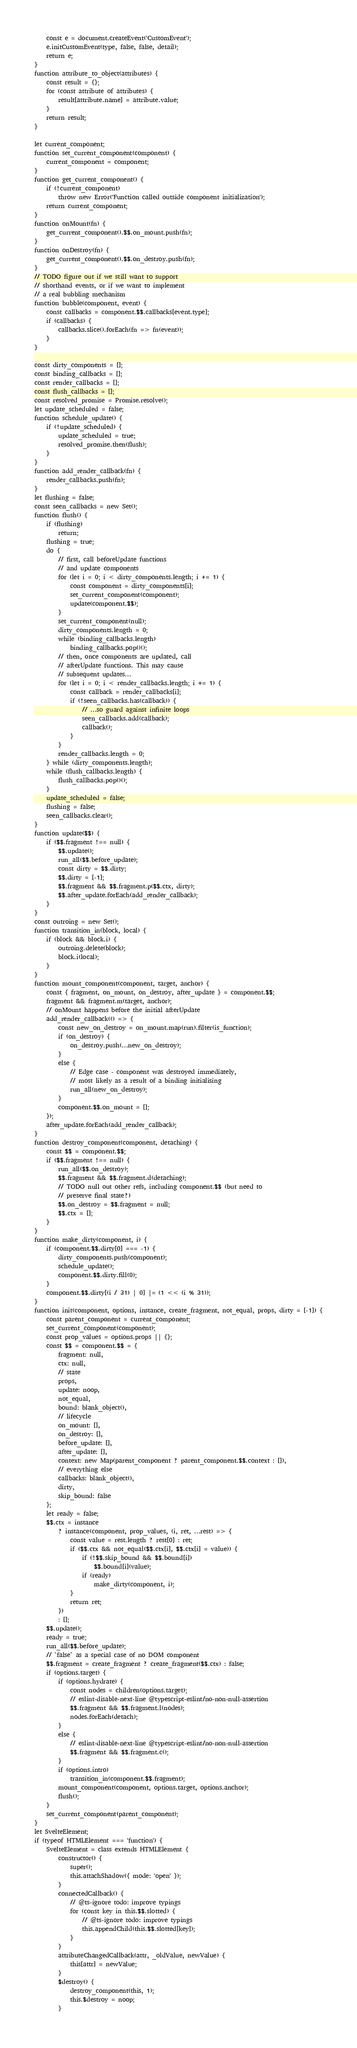Convert code to text. <code><loc_0><loc_0><loc_500><loc_500><_JavaScript_>    const e = document.createEvent('CustomEvent');
    e.initCustomEvent(type, false, false, detail);
    return e;
}
function attribute_to_object(attributes) {
    const result = {};
    for (const attribute of attributes) {
        result[attribute.name] = attribute.value;
    }
    return result;
}

let current_component;
function set_current_component(component) {
    current_component = component;
}
function get_current_component() {
    if (!current_component)
        throw new Error('Function called outside component initialization');
    return current_component;
}
function onMount(fn) {
    get_current_component().$$.on_mount.push(fn);
}
function onDestroy(fn) {
    get_current_component().$$.on_destroy.push(fn);
}
// TODO figure out if we still want to support
// shorthand events, or if we want to implement
// a real bubbling mechanism
function bubble(component, event) {
    const callbacks = component.$$.callbacks[event.type];
    if (callbacks) {
        callbacks.slice().forEach(fn => fn(event));
    }
}

const dirty_components = [];
const binding_callbacks = [];
const render_callbacks = [];
const flush_callbacks = [];
const resolved_promise = Promise.resolve();
let update_scheduled = false;
function schedule_update() {
    if (!update_scheduled) {
        update_scheduled = true;
        resolved_promise.then(flush);
    }
}
function add_render_callback(fn) {
    render_callbacks.push(fn);
}
let flushing = false;
const seen_callbacks = new Set();
function flush() {
    if (flushing)
        return;
    flushing = true;
    do {
        // first, call beforeUpdate functions
        // and update components
        for (let i = 0; i < dirty_components.length; i += 1) {
            const component = dirty_components[i];
            set_current_component(component);
            update(component.$$);
        }
        set_current_component(null);
        dirty_components.length = 0;
        while (binding_callbacks.length)
            binding_callbacks.pop()();
        // then, once components are updated, call
        // afterUpdate functions. This may cause
        // subsequent updates...
        for (let i = 0; i < render_callbacks.length; i += 1) {
            const callback = render_callbacks[i];
            if (!seen_callbacks.has(callback)) {
                // ...so guard against infinite loops
                seen_callbacks.add(callback);
                callback();
            }
        }
        render_callbacks.length = 0;
    } while (dirty_components.length);
    while (flush_callbacks.length) {
        flush_callbacks.pop()();
    }
    update_scheduled = false;
    flushing = false;
    seen_callbacks.clear();
}
function update($$) {
    if ($$.fragment !== null) {
        $$.update();
        run_all($$.before_update);
        const dirty = $$.dirty;
        $$.dirty = [-1];
        $$.fragment && $$.fragment.p($$.ctx, dirty);
        $$.after_update.forEach(add_render_callback);
    }
}
const outroing = new Set();
function transition_in(block, local) {
    if (block && block.i) {
        outroing.delete(block);
        block.i(local);
    }
}
function mount_component(component, target, anchor) {
    const { fragment, on_mount, on_destroy, after_update } = component.$$;
    fragment && fragment.m(target, anchor);
    // onMount happens before the initial afterUpdate
    add_render_callback(() => {
        const new_on_destroy = on_mount.map(run).filter(is_function);
        if (on_destroy) {
            on_destroy.push(...new_on_destroy);
        }
        else {
            // Edge case - component was destroyed immediately,
            // most likely as a result of a binding initialising
            run_all(new_on_destroy);
        }
        component.$$.on_mount = [];
    });
    after_update.forEach(add_render_callback);
}
function destroy_component(component, detaching) {
    const $$ = component.$$;
    if ($$.fragment !== null) {
        run_all($$.on_destroy);
        $$.fragment && $$.fragment.d(detaching);
        // TODO null out other refs, including component.$$ (but need to
        // preserve final state?)
        $$.on_destroy = $$.fragment = null;
        $$.ctx = [];
    }
}
function make_dirty(component, i) {
    if (component.$$.dirty[0] === -1) {
        dirty_components.push(component);
        schedule_update();
        component.$$.dirty.fill(0);
    }
    component.$$.dirty[(i / 31) | 0] |= (1 << (i % 31));
}
function init(component, options, instance, create_fragment, not_equal, props, dirty = [-1]) {
    const parent_component = current_component;
    set_current_component(component);
    const prop_values = options.props || {};
    const $$ = component.$$ = {
        fragment: null,
        ctx: null,
        // state
        props,
        update: noop,
        not_equal,
        bound: blank_object(),
        // lifecycle
        on_mount: [],
        on_destroy: [],
        before_update: [],
        after_update: [],
        context: new Map(parent_component ? parent_component.$$.context : []),
        // everything else
        callbacks: blank_object(),
        dirty,
        skip_bound: false
    };
    let ready = false;
    $$.ctx = instance
        ? instance(component, prop_values, (i, ret, ...rest) => {
            const value = rest.length ? rest[0] : ret;
            if ($$.ctx && not_equal($$.ctx[i], $$.ctx[i] = value)) {
                if (!$$.skip_bound && $$.bound[i])
                    $$.bound[i](value);
                if (ready)
                    make_dirty(component, i);
            }
            return ret;
        })
        : [];
    $$.update();
    ready = true;
    run_all($$.before_update);
    // `false` as a special case of no DOM component
    $$.fragment = create_fragment ? create_fragment($$.ctx) : false;
    if (options.target) {
        if (options.hydrate) {
            const nodes = children(options.target);
            // eslint-disable-next-line @typescript-eslint/no-non-null-assertion
            $$.fragment && $$.fragment.l(nodes);
            nodes.forEach(detach);
        }
        else {
            // eslint-disable-next-line @typescript-eslint/no-non-null-assertion
            $$.fragment && $$.fragment.c();
        }
        if (options.intro)
            transition_in(component.$$.fragment);
        mount_component(component, options.target, options.anchor);
        flush();
    }
    set_current_component(parent_component);
}
let SvelteElement;
if (typeof HTMLElement === 'function') {
    SvelteElement = class extends HTMLElement {
        constructor() {
            super();
            this.attachShadow({ mode: 'open' });
        }
        connectedCallback() {
            // @ts-ignore todo: improve typings
            for (const key in this.$$.slotted) {
                // @ts-ignore todo: improve typings
                this.appendChild(this.$$.slotted[key]);
            }
        }
        attributeChangedCallback(attr, _oldValue, newValue) {
            this[attr] = newValue;
        }
        $destroy() {
            destroy_component(this, 1);
            this.$destroy = noop;
        }</code> 